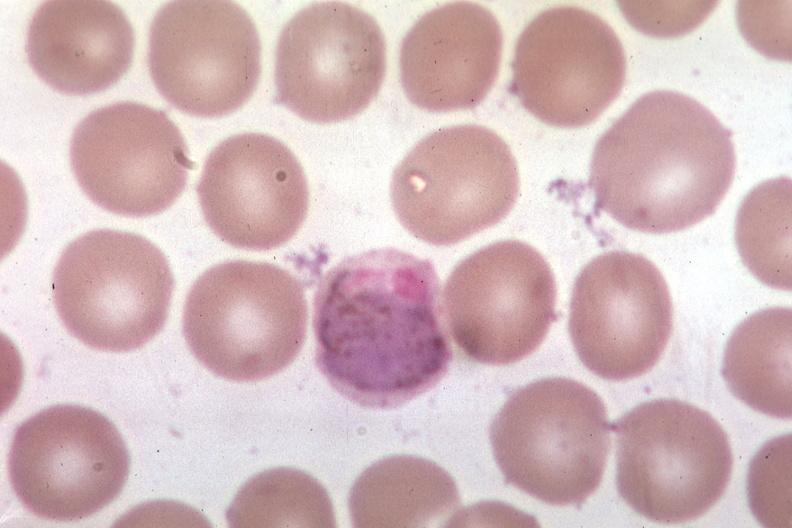s blood present?
Answer the question using a single word or phrase. Yes 